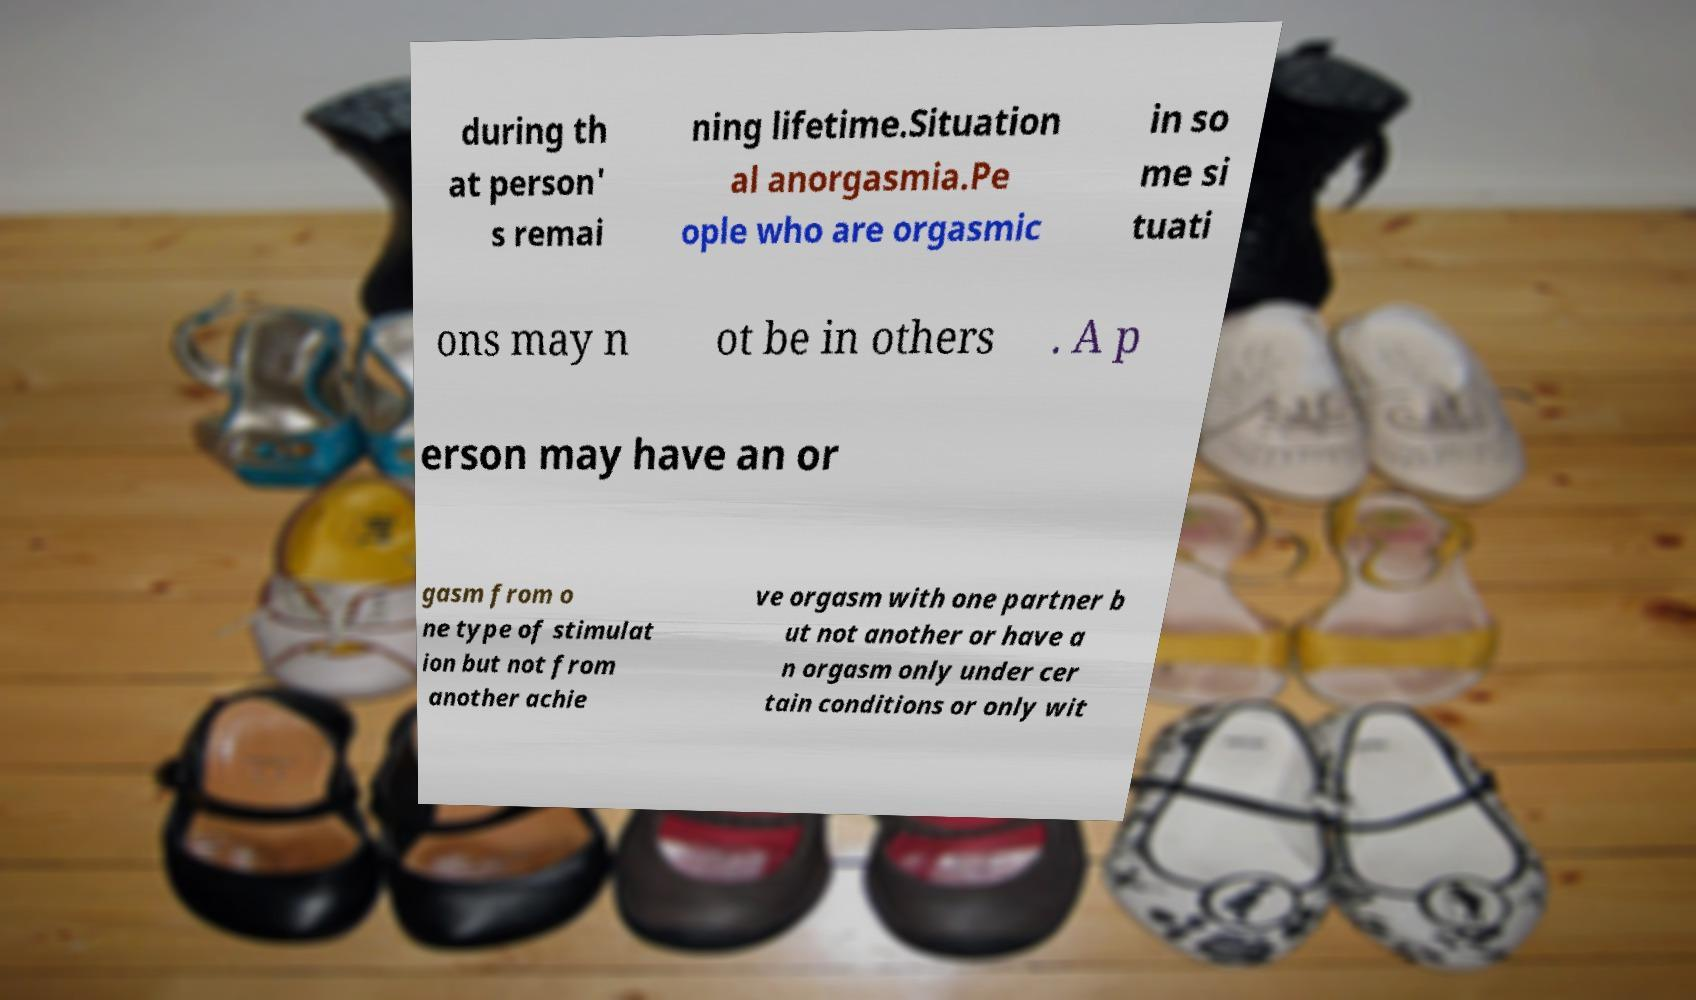There's text embedded in this image that I need extracted. Can you transcribe it verbatim? during th at person' s remai ning lifetime.Situation al anorgasmia.Pe ople who are orgasmic in so me si tuati ons may n ot be in others . A p erson may have an or gasm from o ne type of stimulat ion but not from another achie ve orgasm with one partner b ut not another or have a n orgasm only under cer tain conditions or only wit 